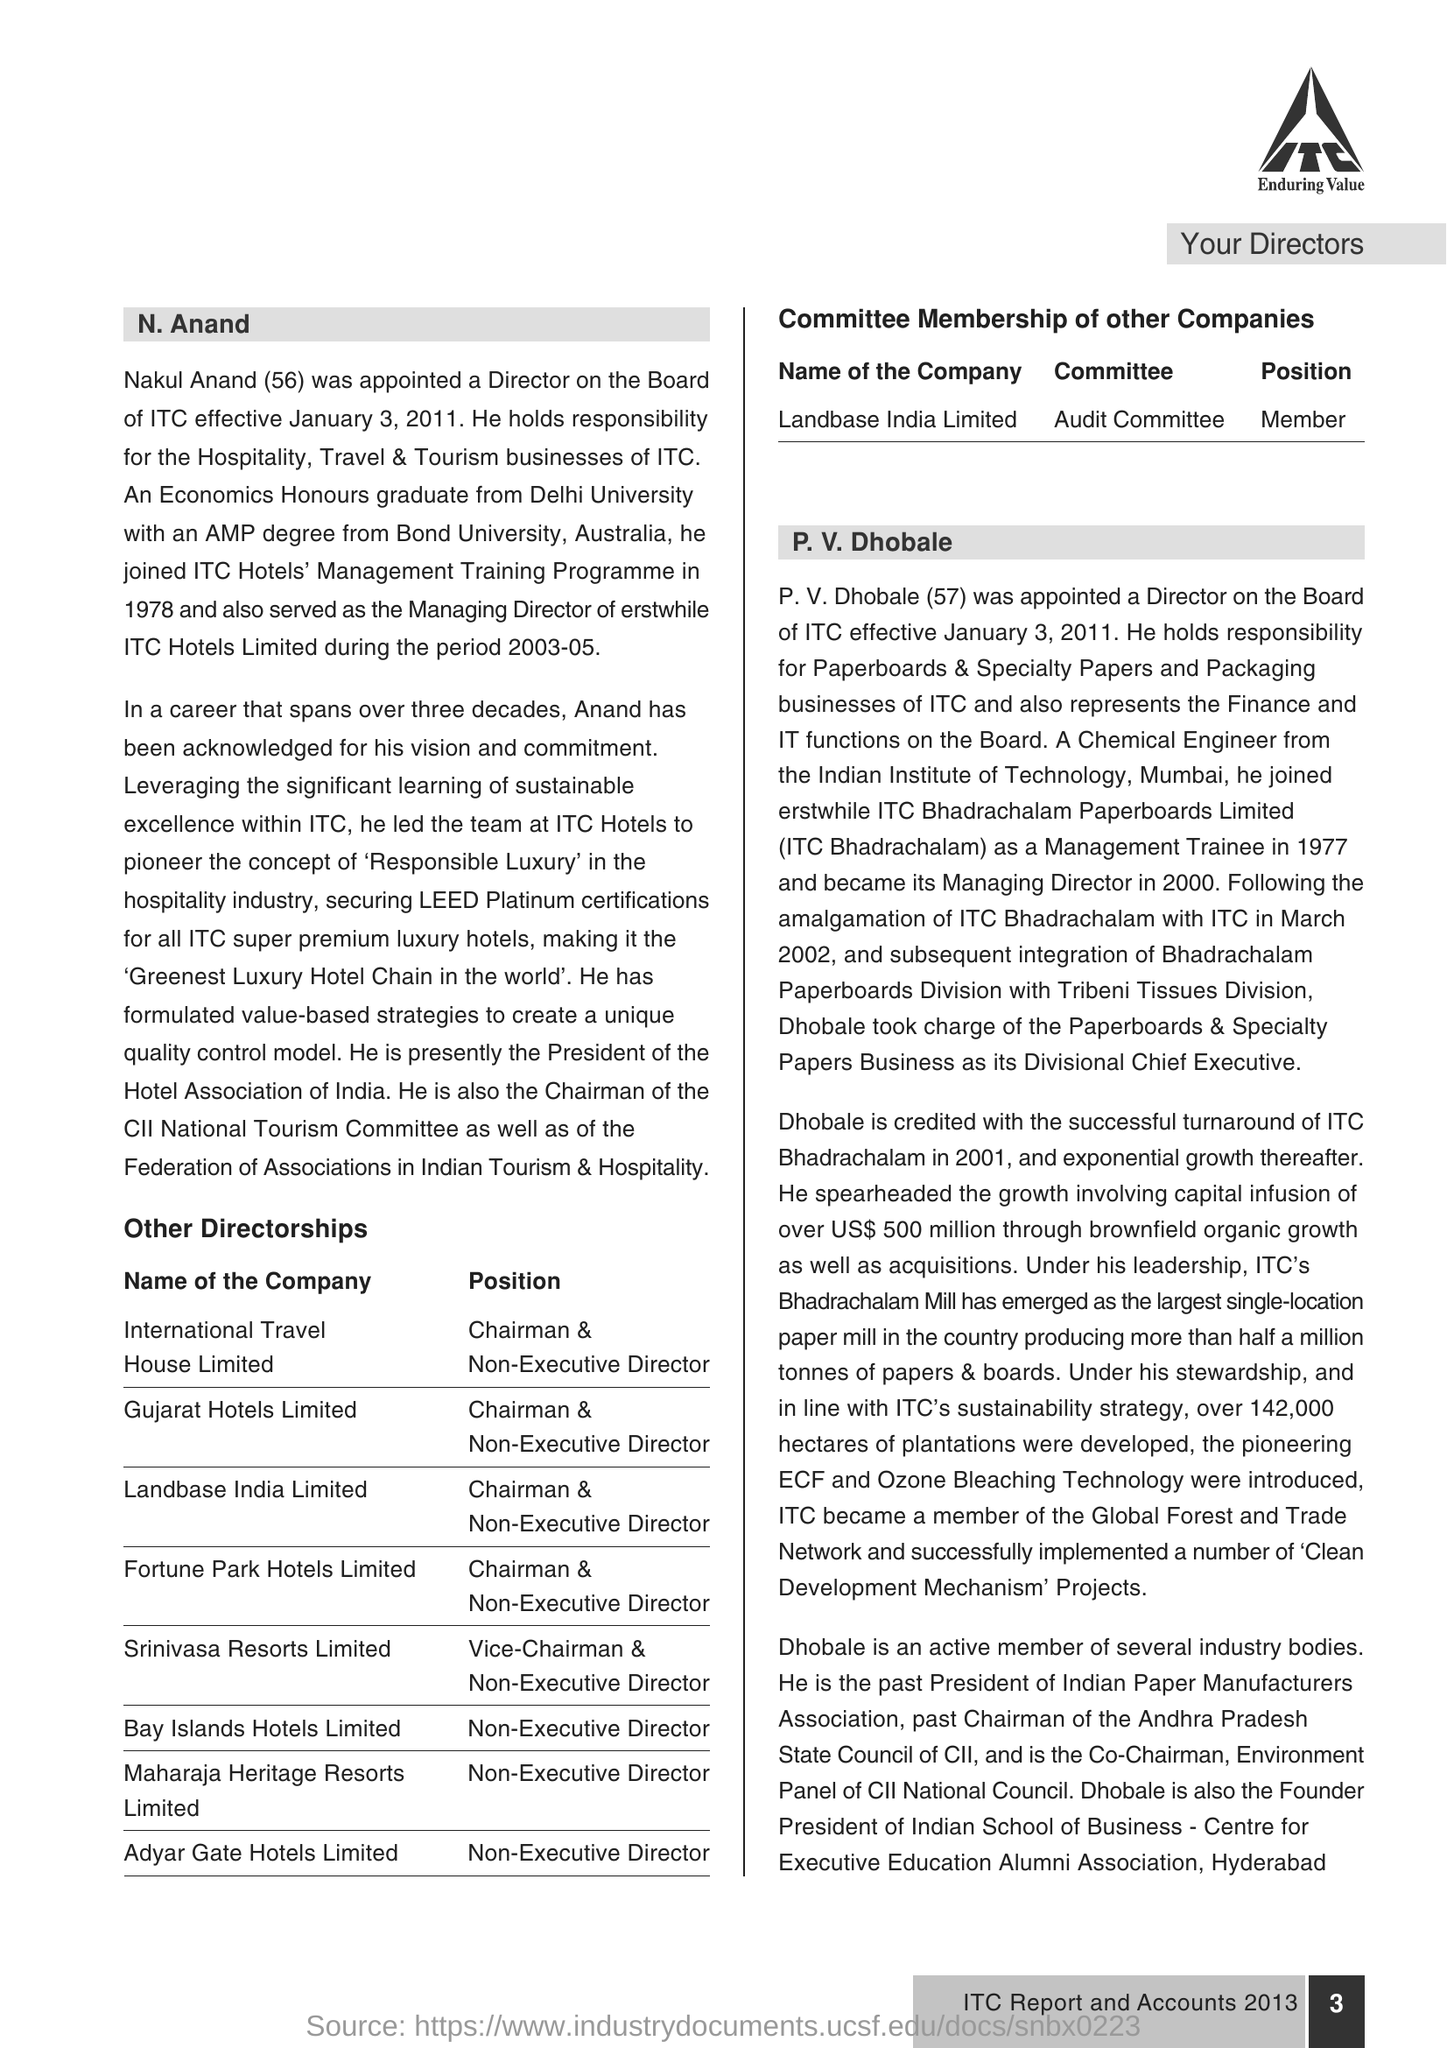Age of P.V Dhobale?
Keep it short and to the point. 57. When N Anand was appointed?
Offer a terse response. January 3, 2011. What is the age of N Anand?
Make the answer very short. 56. Full name of N Anand?
Make the answer very short. Nakul Anand. 